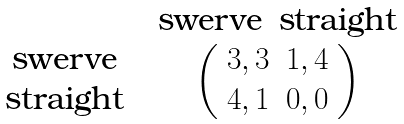<formula> <loc_0><loc_0><loc_500><loc_500>\begin{array} { c c } & \begin{array} { c c } \text {swerve} & \text {straight} \end{array} \\ \begin{array} { c } \text {swerve} \\ \text {straight} \end{array} & \left ( \begin{array} { c c } 3 , 3 & 1 , 4 \\ 4 , 1 & 0 , 0 \end{array} \right ) \end{array}</formula> 